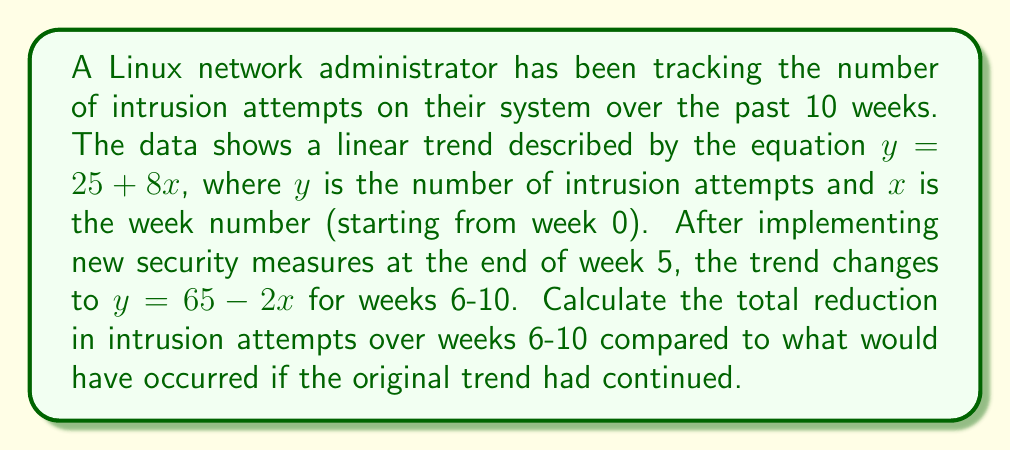Teach me how to tackle this problem. To solve this problem, we need to follow these steps:

1. Calculate the number of intrusion attempts for weeks 6-10 using the original trend.
2. Calculate the actual number of intrusion attempts for weeks 6-10 using the new trend.
3. Find the difference between these two totals.

Step 1: Original trend ($y = 25 + 8x$)
For weeks 6-10, we calculate:
Week 6: $y = 25 + 8(6) = 73$
Week 7: $y = 25 + 8(7) = 81$
Week 8: $y = 25 + 8(8) = 89$
Week 9: $y = 25 + 8(9) = 97$
Week 10: $y = 25 + 8(10) = 105$

Total: $73 + 81 + 89 + 97 + 105 = 445$

Step 2: New trend ($y = 65 - 2x$)
For weeks 6-10, we calculate:
Week 6: $y = 65 - 2(6) = 53$
Week 7: $y = 65 - 2(7) = 51$
Week 8: $y = 65 - 2(8) = 49$
Week 9: $y = 65 - 2(9) = 47$
Week 10: $y = 65 - 2(10) = 45$

Total: $53 + 51 + 49 + 47 + 45 = 245$

Step 3: Difference
Total reduction = Original trend total - New trend total
$= 445 - 245 = 200$

Therefore, the total reduction in intrusion attempts over weeks 6-10 is 200.
Answer: 200 intrusion attempts 